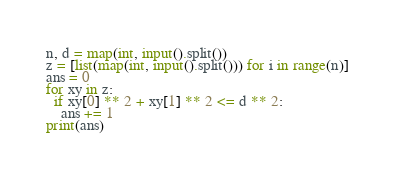Convert code to text. <code><loc_0><loc_0><loc_500><loc_500><_Python_>n, d = map(int, input().split())
z = [list(map(int, input().split())) for i in range(n)]
ans = 0
for xy in z:
  if xy[0] ** 2 + xy[1] ** 2 <= d ** 2:
    ans += 1
print(ans)</code> 